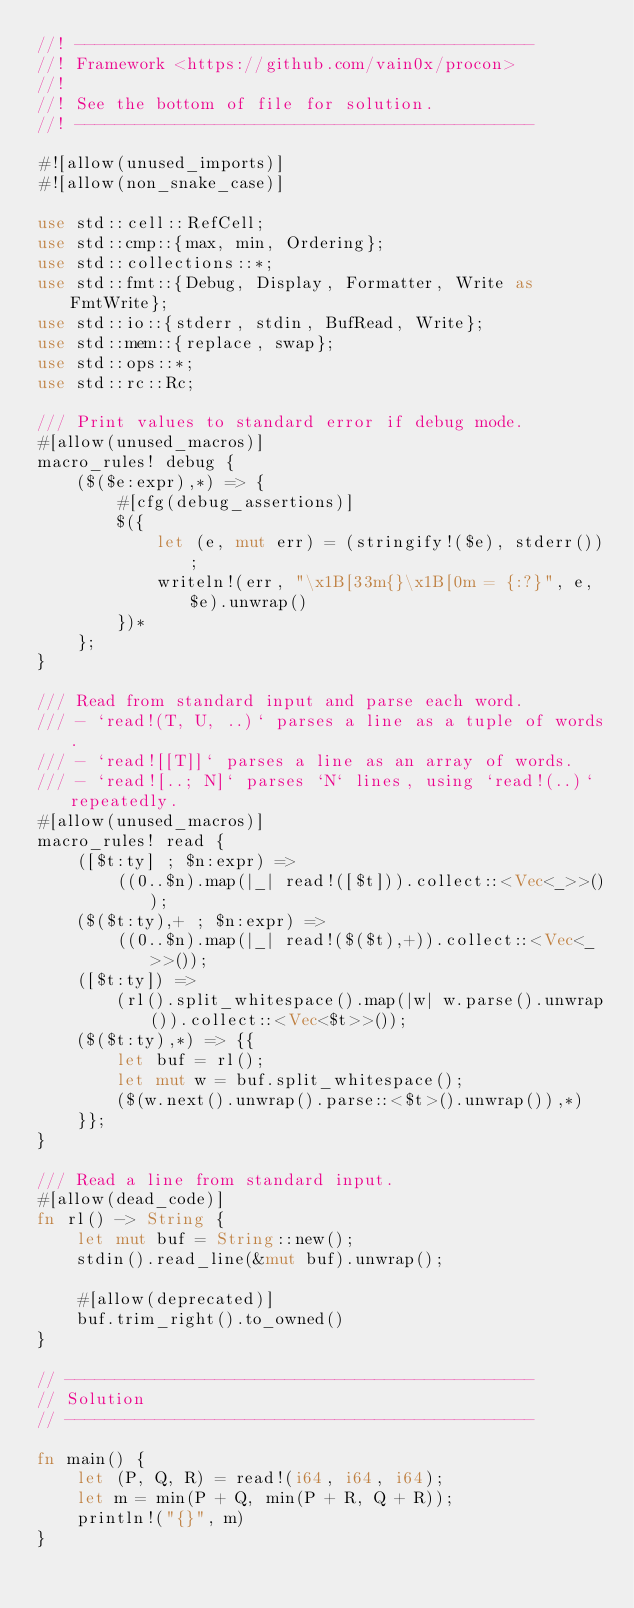<code> <loc_0><loc_0><loc_500><loc_500><_Rust_>//! ----------------------------------------------
//! Framework <https://github.com/vain0x/procon>
//!
//! See the bottom of file for solution.
//! ----------------------------------------------

#![allow(unused_imports)]
#![allow(non_snake_case)]

use std::cell::RefCell;
use std::cmp::{max, min, Ordering};
use std::collections::*;
use std::fmt::{Debug, Display, Formatter, Write as FmtWrite};
use std::io::{stderr, stdin, BufRead, Write};
use std::mem::{replace, swap};
use std::ops::*;
use std::rc::Rc;

/// Print values to standard error if debug mode.
#[allow(unused_macros)]
macro_rules! debug {
    ($($e:expr),*) => {
        #[cfg(debug_assertions)]
        $({
            let (e, mut err) = (stringify!($e), stderr());
            writeln!(err, "\x1B[33m{}\x1B[0m = {:?}", e, $e).unwrap()
        })*
    };
}

/// Read from standard input and parse each word.
/// - `read!(T, U, ..)` parses a line as a tuple of words.
/// - `read![[T]]` parses a line as an array of words.
/// - `read![..; N]` parses `N` lines, using `read!(..)` repeatedly.
#[allow(unused_macros)]
macro_rules! read {
    ([$t:ty] ; $n:expr) =>
        ((0..$n).map(|_| read!([$t])).collect::<Vec<_>>());
    ($($t:ty),+ ; $n:expr) =>
        ((0..$n).map(|_| read!($($t),+)).collect::<Vec<_>>());
    ([$t:ty]) =>
        (rl().split_whitespace().map(|w| w.parse().unwrap()).collect::<Vec<$t>>());
    ($($t:ty),*) => {{
        let buf = rl();
        let mut w = buf.split_whitespace();
        ($(w.next().unwrap().parse::<$t>().unwrap()),*)
    }};
}

/// Read a line from standard input.
#[allow(dead_code)]
fn rl() -> String {
    let mut buf = String::new();
    stdin().read_line(&mut buf).unwrap();

    #[allow(deprecated)]
    buf.trim_right().to_owned()
}

// -----------------------------------------------
// Solution
// -----------------------------------------------

fn main() {
    let (P, Q, R) = read!(i64, i64, i64);
    let m = min(P + Q, min(P + R, Q + R));
    println!("{}", m)
}
</code> 